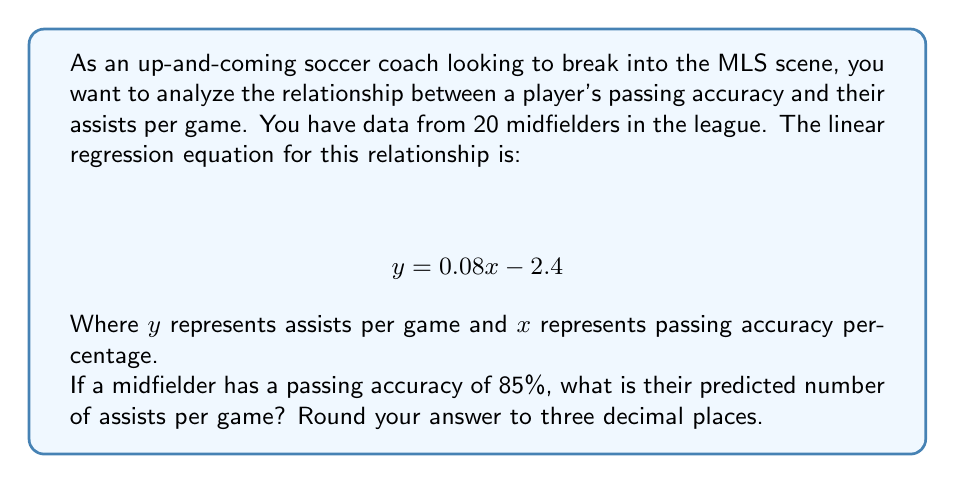Could you help me with this problem? To solve this problem, we need to use the given linear regression equation and substitute the known value for the passing accuracy percentage. Here's the step-by-step process:

1. The linear regression equation is:
   $$ y = 0.08x - 2.4 $$
   Where:
   $y$ = assists per game
   $x$ = passing accuracy percentage

2. We're given that the midfielder has a passing accuracy of 85%, so $x = 85$.

3. Let's substitute this value into the equation:
   $$ y = 0.08(85) - 2.4 $$

4. Now, let's solve the equation:
   $$ y = 6.8 - 2.4 $$
   $$ y = 4.4 $$

5. The question asks for the answer rounded to three decimal places:
   $$ y \approx 4.400 $$

This means that for a midfielder with a passing accuracy of 85%, the model predicts 4.400 assists per game.

It's important to note that in reality, assists per game would typically be much lower. This model might be exaggerating the relationship or might need to be adjusted. As a coach, you'd want to consider other factors and perhaps refine the model for more realistic predictions.
Answer: 4.400 assists per game 